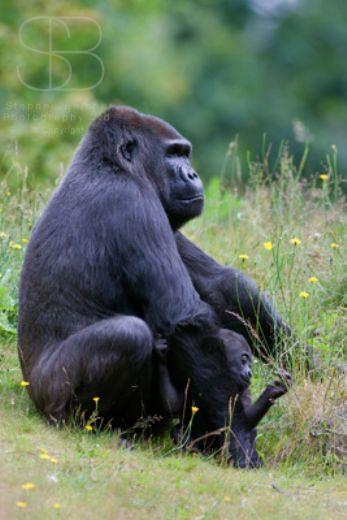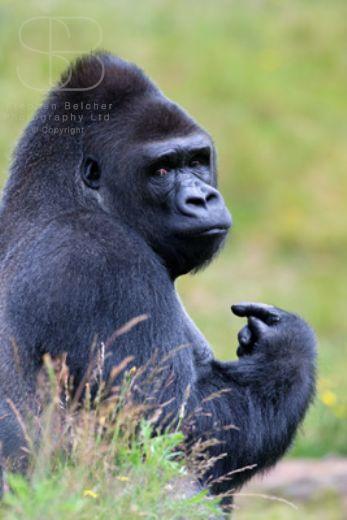The first image is the image on the left, the second image is the image on the right. Given the left and right images, does the statement "The left image contains a gorilla sitting down and looking towards the right." hold true? Answer yes or no. Yes. 